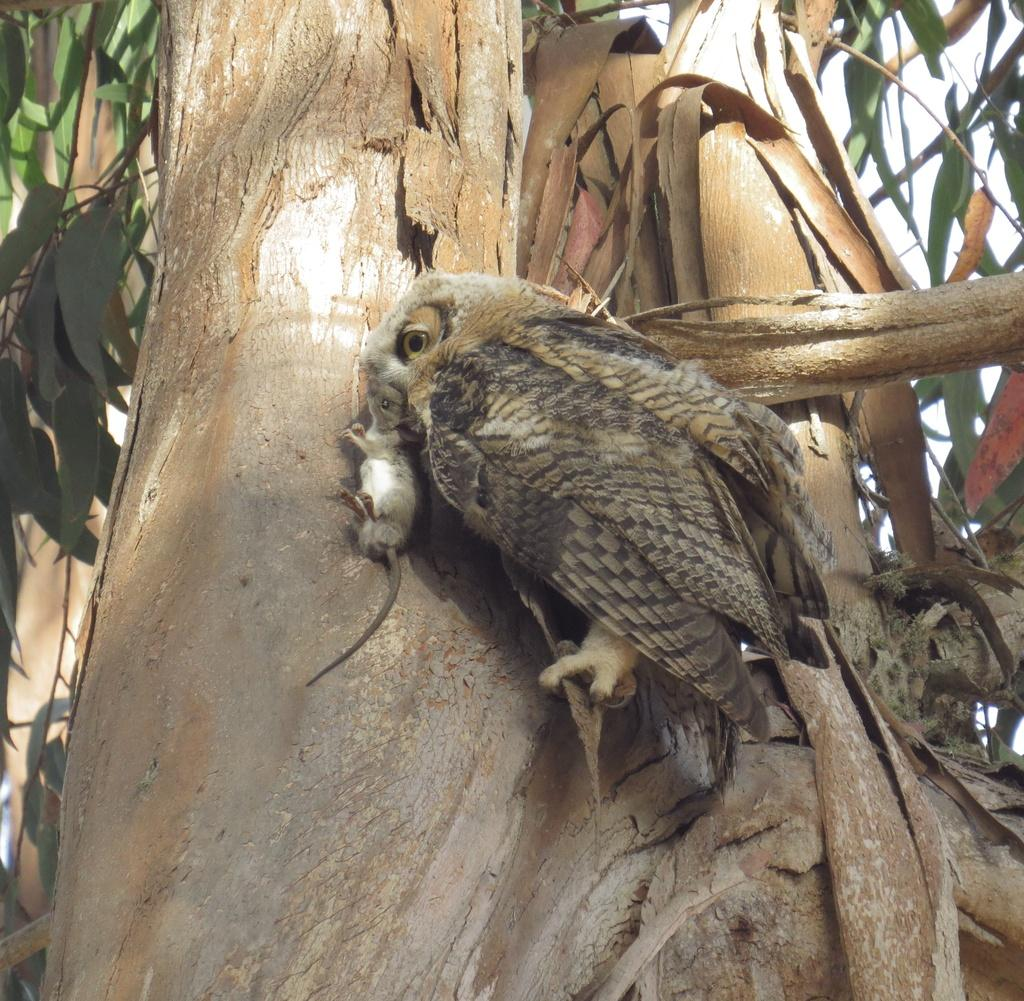What is the main object in the image? There is a tree in the image. Is there any animal on the tree? Yes, an owl is present on the tree. What is the owl doing in the image? The owl is holding a rat. What can be seen in the top right side of the image? The sky is visible in the top right side of the image. What is the taste of the bomb in the image? There is no bomb present in the image, so it cannot be tasted. 